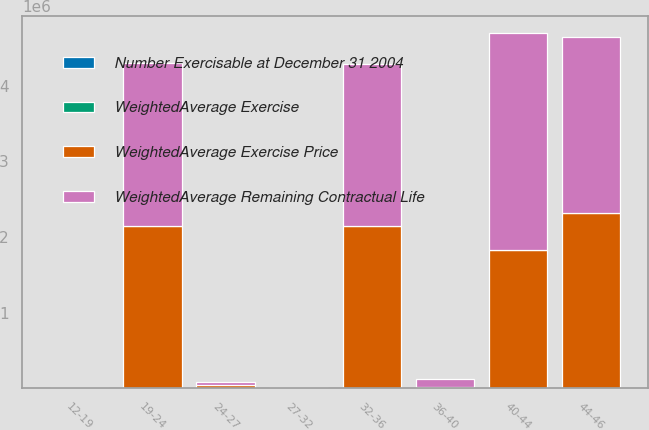<chart> <loc_0><loc_0><loc_500><loc_500><stacked_bar_chart><ecel><fcel>12-19<fcel>19-24<fcel>24-27<fcel>27-32<fcel>32-36<fcel>36-40<fcel>40-44<fcel>44-46<nl><fcel>WeightedAverage Remaining Contractual Life<fcel>3817<fcel>2.14633e+06<fcel>42163<fcel>43.55<fcel>2.14334e+06<fcel>101519<fcel>2.86677e+06<fcel>2.32447e+06<nl><fcel>WeightedAverage Exercise<fcel>1<fcel>1.9<fcel>2.1<fcel>5.1<fcel>4.2<fcel>7.6<fcel>6.8<fcel>3<nl><fcel>Number Exercisable at December 31 2004<fcel>18.18<fcel>23.33<fcel>26.13<fcel>30.6<fcel>33.39<fcel>36.78<fcel>42.05<fcel>45.05<nl><fcel>WeightedAverage Exercise Price<fcel>3817<fcel>2.14633e+06<fcel>42163<fcel>43.55<fcel>2.14334e+06<fcel>16496<fcel>1.82238e+06<fcel>2.31785e+06<nl></chart> 